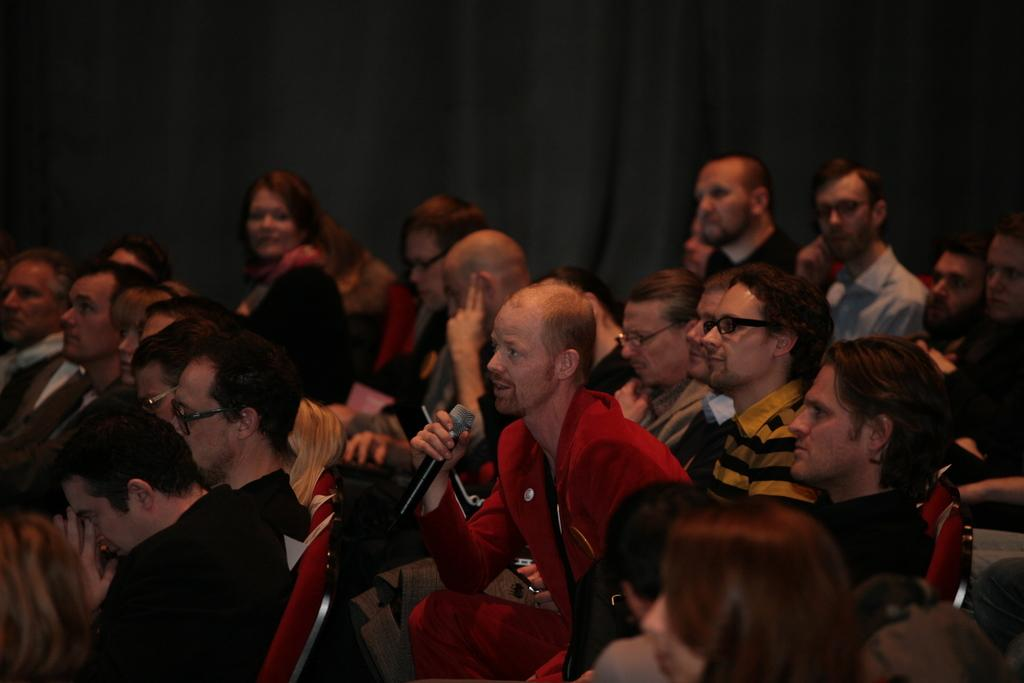What are the persons sitting on in the image? The persons are sitting on red chairs. Can you describe any accessories that some persons are wearing? Some persons are wearing spectacles. What is the man wearing in the image? The man is wearing a red shirt. What is the man holding in the image? The man is holding a mic. Is the man playing a guitar in the image? There is no guitar present in the image. Can you see the man's tongue in the image? The image does not show the man's tongue. 